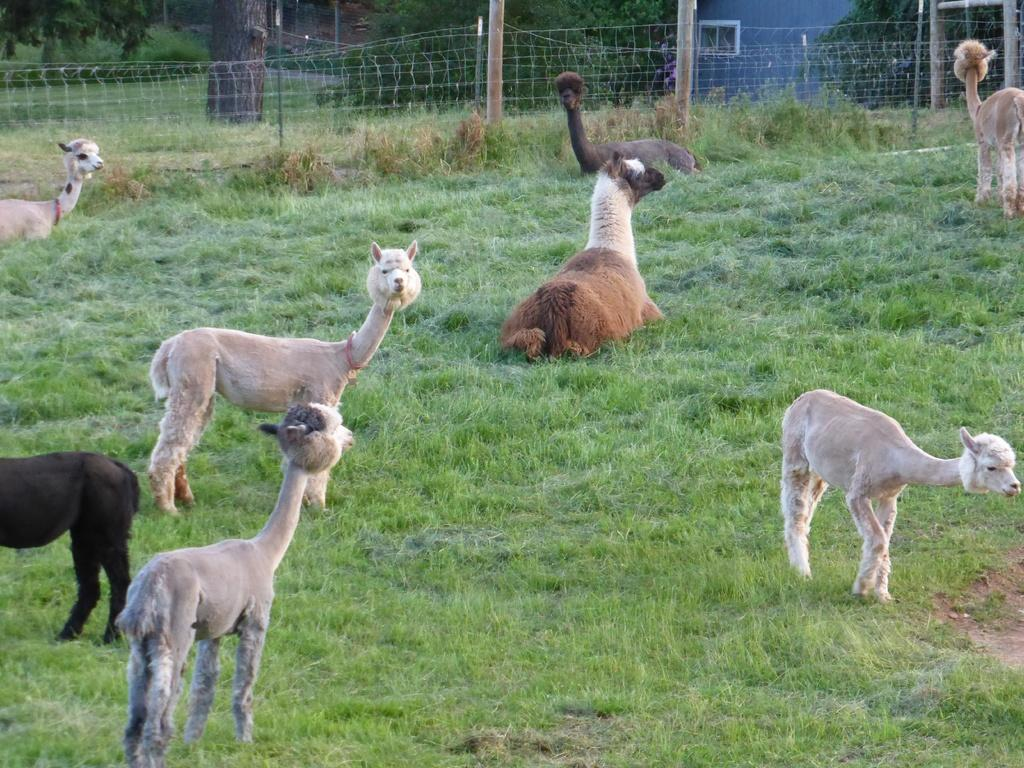What type of animals can be seen on the ground in the image? There are animals on the ground in the image, but their specific type is not mentioned in the facts. What can be seen in the background of the image? There are trees in the image, as well as grass. What structures are present in the image? There are poles and a fence in the image. Can you tell me how the stranger's health is in the image? There is no stranger present in the image, so it is not possible to comment on their health. How do the animals move around in the image? The movement of the animals is not mentioned in the facts, so it cannot be determined from the image. 